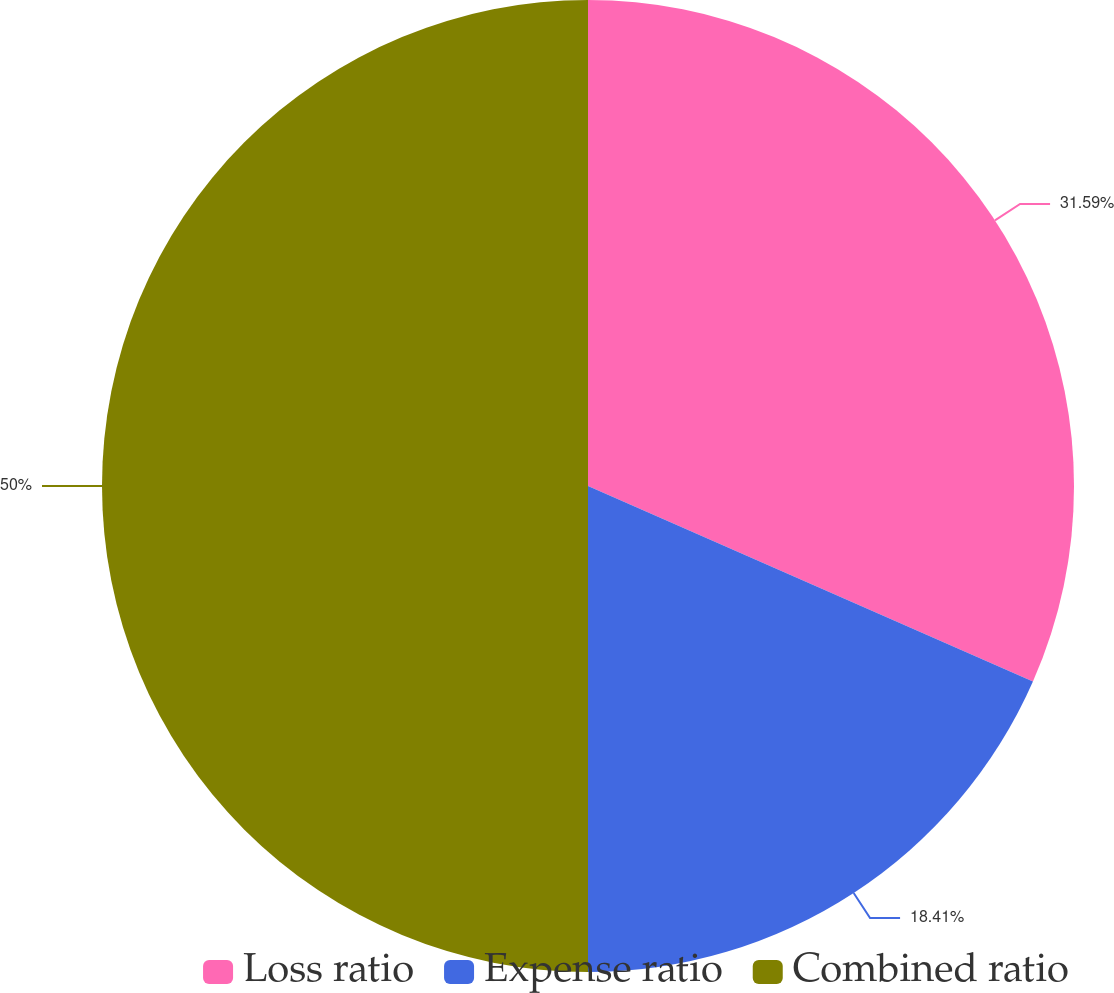Convert chart to OTSL. <chart><loc_0><loc_0><loc_500><loc_500><pie_chart><fcel>Loss ratio<fcel>Expense ratio<fcel>Combined ratio<nl><fcel>31.59%<fcel>18.41%<fcel>50.0%<nl></chart> 